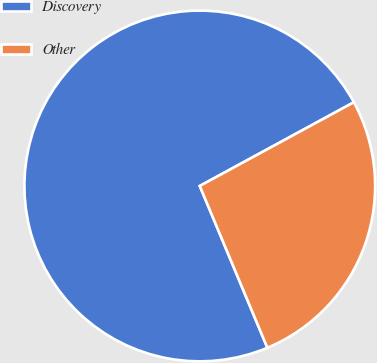Convert chart. <chart><loc_0><loc_0><loc_500><loc_500><pie_chart><fcel>Discovery<fcel>Other<nl><fcel>73.38%<fcel>26.62%<nl></chart> 